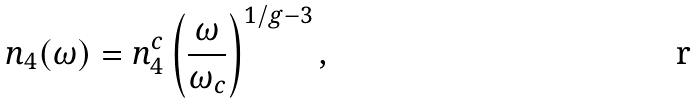Convert formula to latex. <formula><loc_0><loc_0><loc_500><loc_500>n _ { 4 } ( \omega ) = n ^ { c } _ { 4 } \left ( \frac { \omega } { \omega _ { c } } \right ) ^ { 1 / g - 3 } ,</formula> 